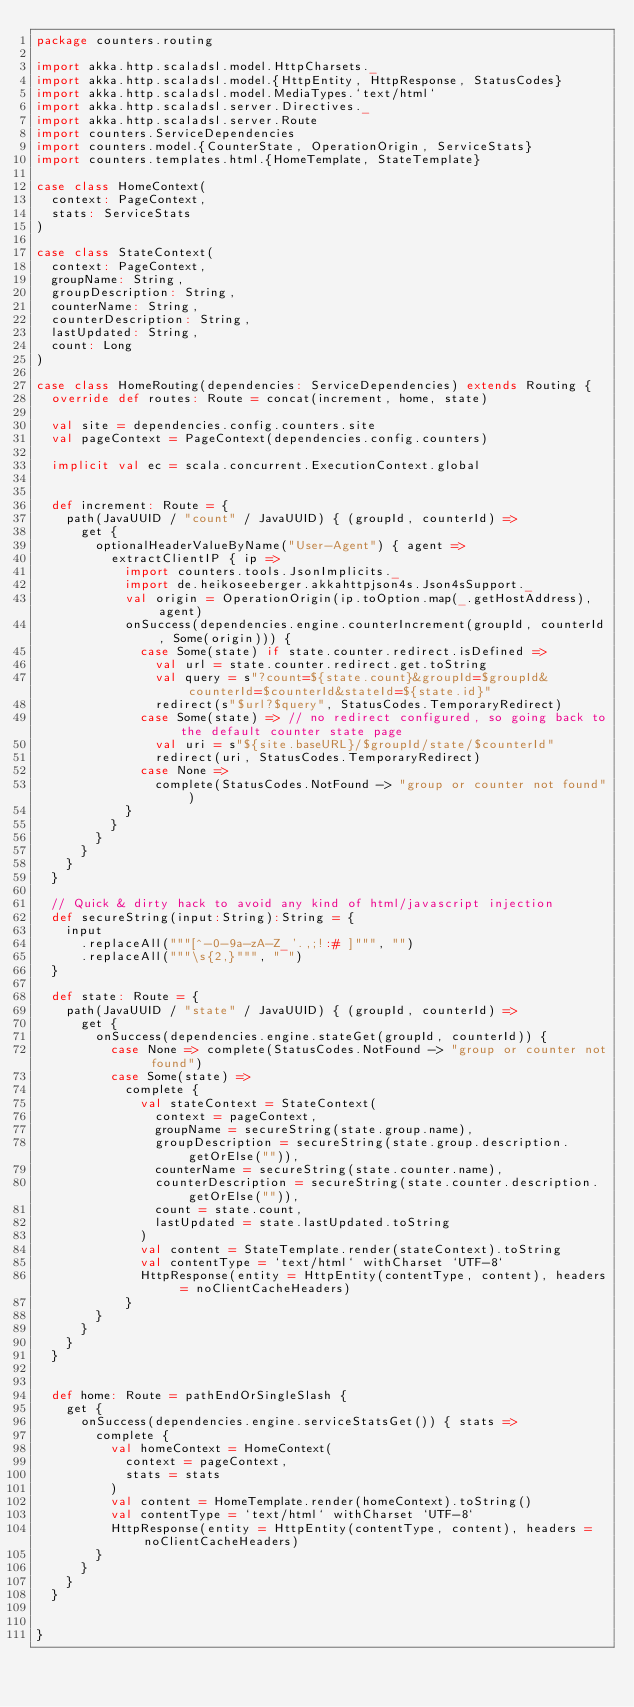<code> <loc_0><loc_0><loc_500><loc_500><_Scala_>package counters.routing

import akka.http.scaladsl.model.HttpCharsets._
import akka.http.scaladsl.model.{HttpEntity, HttpResponse, StatusCodes}
import akka.http.scaladsl.model.MediaTypes.`text/html`
import akka.http.scaladsl.server.Directives._
import akka.http.scaladsl.server.Route
import counters.ServiceDependencies
import counters.model.{CounterState, OperationOrigin, ServiceStats}
import counters.templates.html.{HomeTemplate, StateTemplate}

case class HomeContext(
  context: PageContext,
  stats: ServiceStats
)

case class StateContext(
  context: PageContext,
  groupName: String,
  groupDescription: String,
  counterName: String,
  counterDescription: String,
  lastUpdated: String,
  count: Long
)

case class HomeRouting(dependencies: ServiceDependencies) extends Routing {
  override def routes: Route = concat(increment, home, state)

  val site = dependencies.config.counters.site
  val pageContext = PageContext(dependencies.config.counters)

  implicit val ec = scala.concurrent.ExecutionContext.global


  def increment: Route = {
    path(JavaUUID / "count" / JavaUUID) { (groupId, counterId) =>
      get {
        optionalHeaderValueByName("User-Agent") { agent =>
          extractClientIP { ip =>
            import counters.tools.JsonImplicits._
            import de.heikoseeberger.akkahttpjson4s.Json4sSupport._
            val origin = OperationOrigin(ip.toOption.map(_.getHostAddress), agent)
            onSuccess(dependencies.engine.counterIncrement(groupId, counterId, Some(origin))) {
              case Some(state) if state.counter.redirect.isDefined =>
                val url = state.counter.redirect.get.toString
                val query = s"?count=${state.count}&groupId=$groupId&counterId=$counterId&stateId=${state.id}"
                redirect(s"$url?$query", StatusCodes.TemporaryRedirect)
              case Some(state) => // no redirect configured, so going back to the default counter state page
                val uri = s"${site.baseURL}/$groupId/state/$counterId"
                redirect(uri, StatusCodes.TemporaryRedirect)
              case None =>
                complete(StatusCodes.NotFound -> "group or counter not found")
            }
          }
        }
      }
    }
  }

  // Quick & dirty hack to avoid any kind of html/javascript injection
  def secureString(input:String):String = {
    input
      .replaceAll("""[^-0-9a-zA-Z_'.,;!:# ]""", "")
      .replaceAll("""\s{2,}""", " ")
  }

  def state: Route = {
    path(JavaUUID / "state" / JavaUUID) { (groupId, counterId) =>
      get {
        onSuccess(dependencies.engine.stateGet(groupId, counterId)) {
          case None => complete(StatusCodes.NotFound -> "group or counter not found")
          case Some(state) =>
            complete {
              val stateContext = StateContext(
                context = pageContext,
                groupName = secureString(state.group.name),
                groupDescription = secureString(state.group.description.getOrElse("")),
                counterName = secureString(state.counter.name),
                counterDescription = secureString(state.counter.description.getOrElse("")),
                count = state.count,
                lastUpdated = state.lastUpdated.toString
              )
              val content = StateTemplate.render(stateContext).toString
              val contentType = `text/html` withCharset `UTF-8`
              HttpResponse(entity = HttpEntity(contentType, content), headers = noClientCacheHeaders)
            }
        }
      }
    }
  }


  def home: Route = pathEndOrSingleSlash {
    get {
      onSuccess(dependencies.engine.serviceStatsGet()) { stats =>
        complete {
          val homeContext = HomeContext(
            context = pageContext,
            stats = stats
          )
          val content = HomeTemplate.render(homeContext).toString()
          val contentType = `text/html` withCharset `UTF-8`
          HttpResponse(entity = HttpEntity(contentType, content), headers = noClientCacheHeaders)
        }
      }
    }
  }


}
</code> 